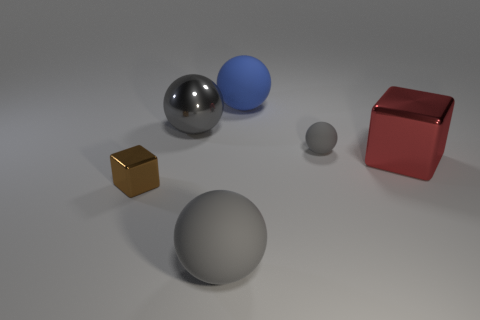Subtract all cyan blocks. How many gray balls are left? 3 Subtract 1 balls. How many balls are left? 3 Add 3 large green cylinders. How many objects exist? 9 Subtract all balls. How many objects are left? 2 Add 6 large red metallic things. How many large red metallic things exist? 7 Subtract 0 gray blocks. How many objects are left? 6 Subtract all purple matte blocks. Subtract all big balls. How many objects are left? 3 Add 5 small spheres. How many small spheres are left? 6 